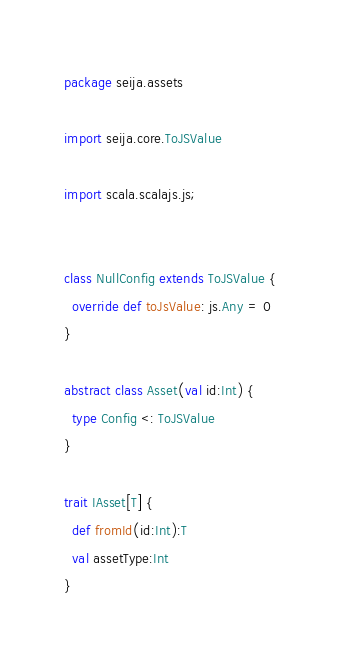<code> <loc_0><loc_0><loc_500><loc_500><_Scala_>package seija.assets

import seija.core.ToJSValue

import scala.scalajs.js;


class NullConfig extends ToJSValue {
  override def toJsValue: js.Any = 0
}

abstract class Asset(val id:Int) {
  type Config <: ToJSValue
}

trait IAsset[T] {
  def fromId(id:Int):T
  val assetType:Int
}</code> 